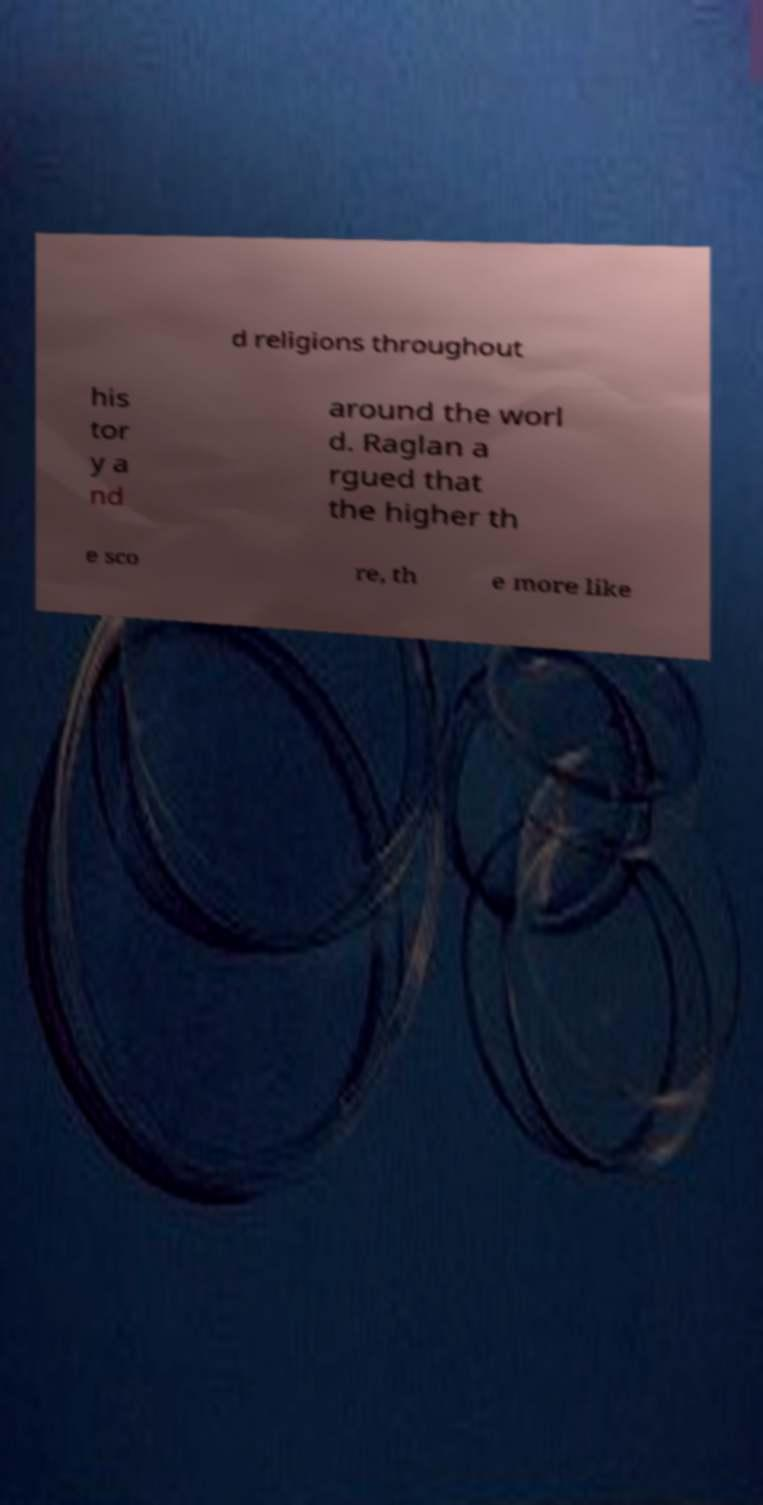Can you accurately transcribe the text from the provided image for me? d religions throughout his tor y a nd around the worl d. Raglan a rgued that the higher th e sco re, th e more like 